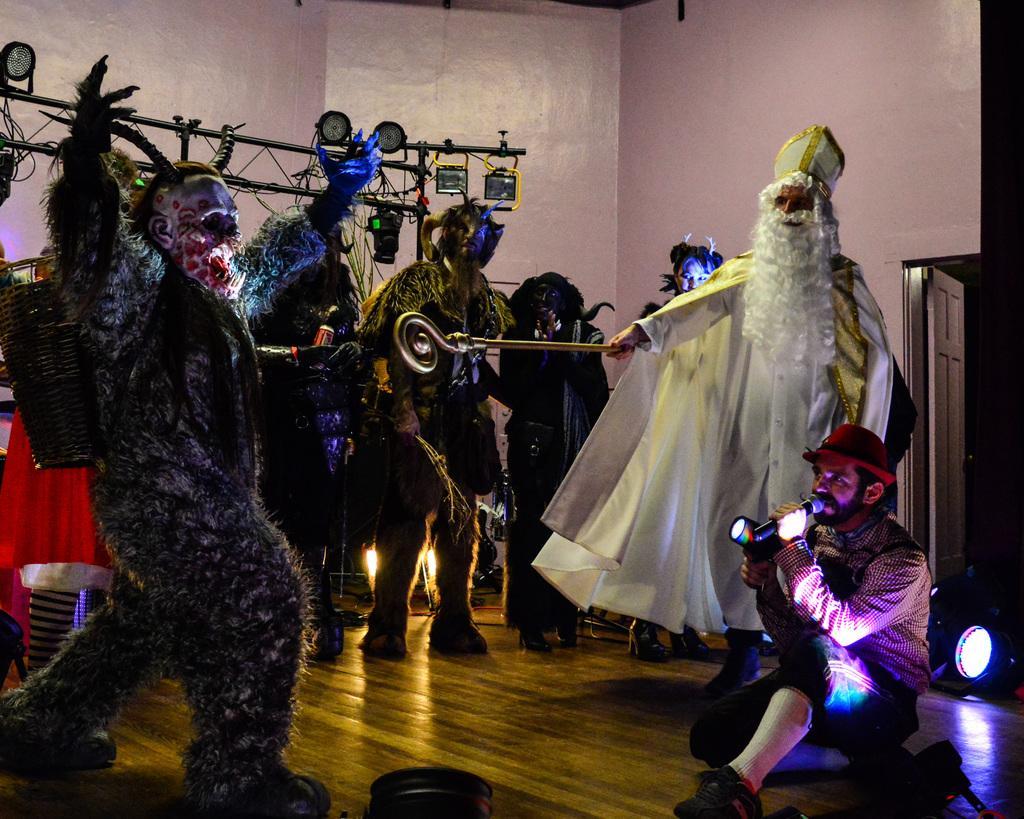Can you describe this image briefly? There are many people wearing costumes. In the back there is a stand. On the right side there is a person sitting and holding a mic and a light. Also there is another light on the right side. In the back there is a wall. 